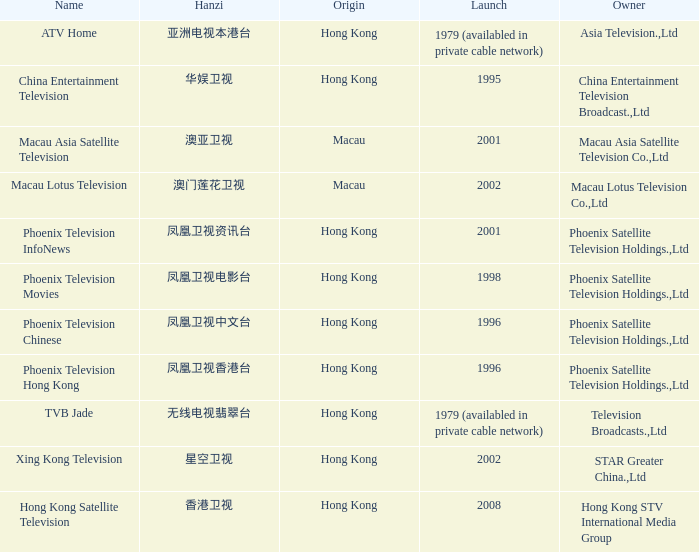What is the Hanzi of Phoenix Television Chinese that launched in 1996? 凤凰卫视中文台. 